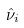<formula> <loc_0><loc_0><loc_500><loc_500>\hat { \nu } _ { i }</formula> 